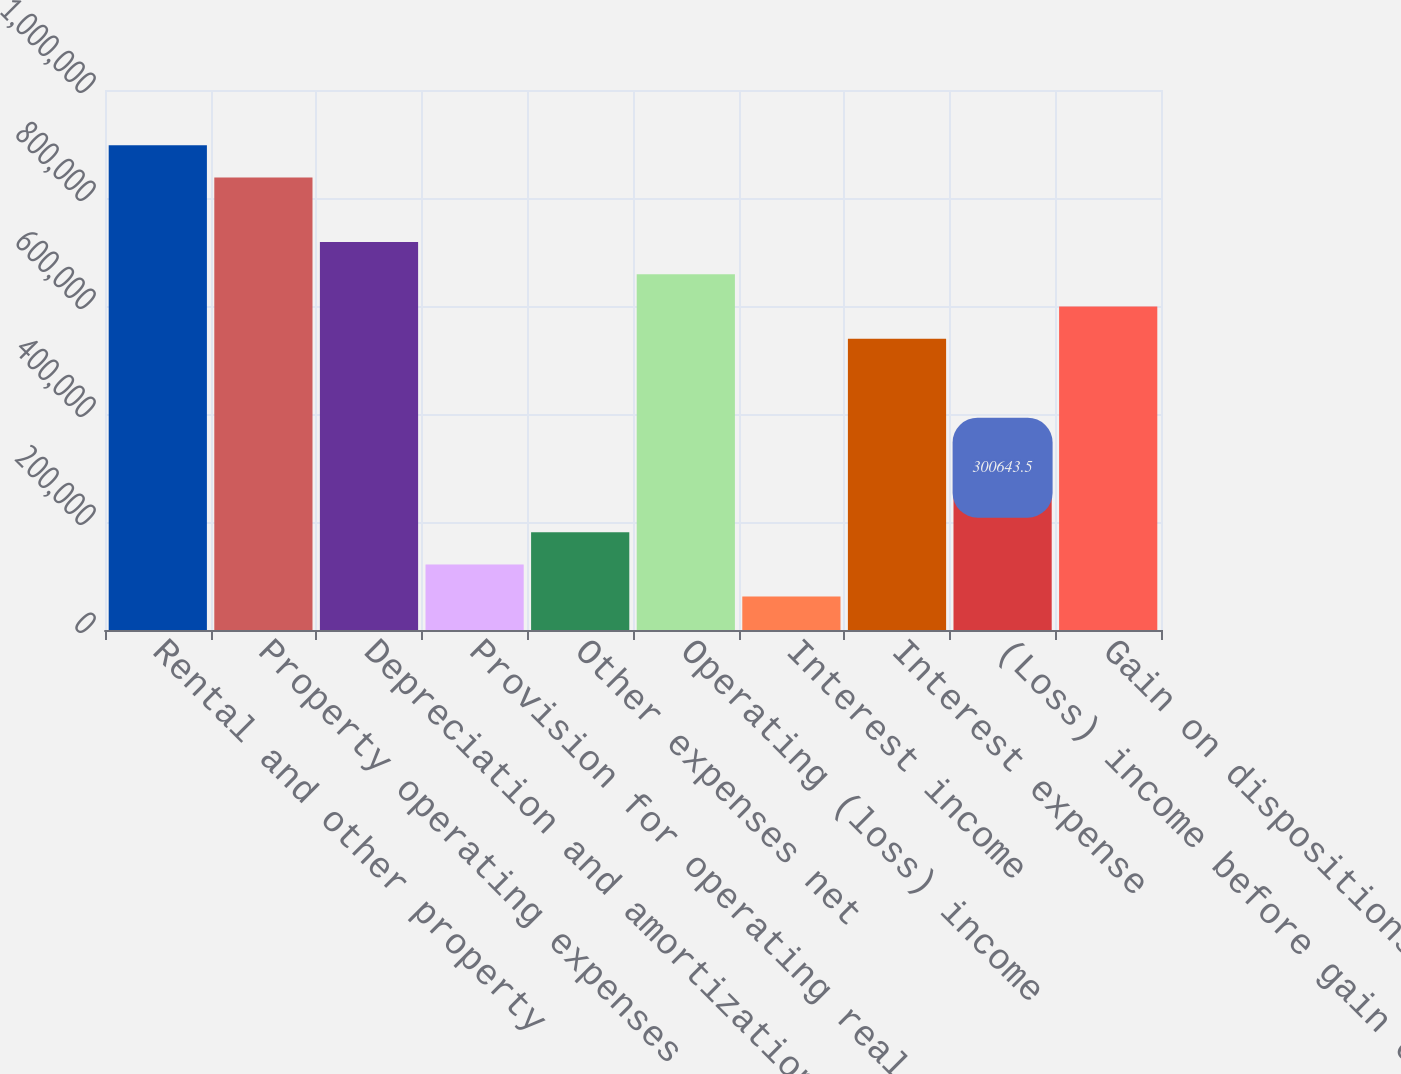Convert chart. <chart><loc_0><loc_0><loc_500><loc_500><bar_chart><fcel>Rental and other property<fcel>Property operating expenses<fcel>Depreciation and amortization<fcel>Provision for operating real<fcel>Other expenses net<fcel>Operating (loss) income<fcel>Interest income<fcel>Interest expense<fcel>(Loss) income before gain on<fcel>Gain on dispositions of real<nl><fcel>897722<fcel>838015<fcel>718599<fcel>121520<fcel>181228<fcel>658891<fcel>61811.9<fcel>539475<fcel>300644<fcel>599183<nl></chart> 